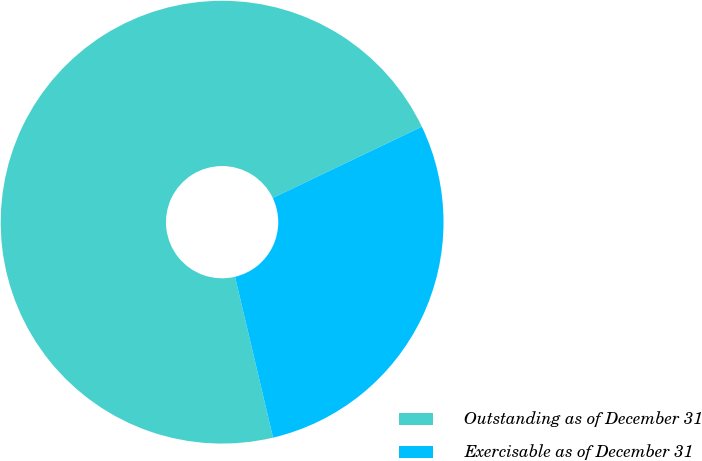<chart> <loc_0><loc_0><loc_500><loc_500><pie_chart><fcel>Outstanding as of December 31<fcel>Exercisable as of December 31<nl><fcel>71.6%<fcel>28.4%<nl></chart> 